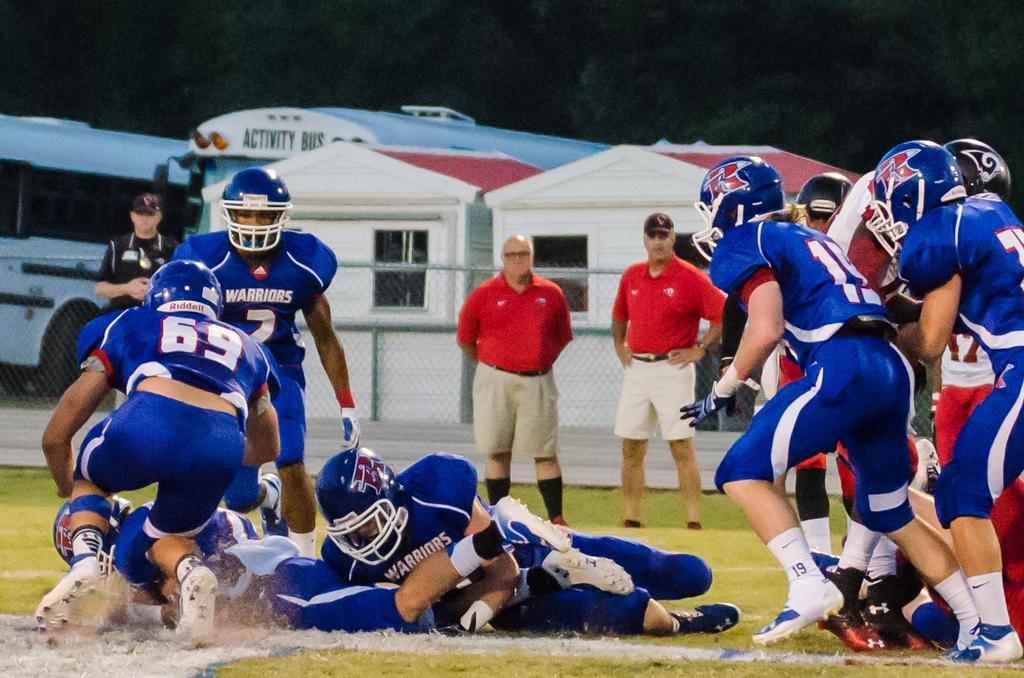How many people are in the image? There is a group of people in the image, but the exact number is not specified. What is the position of the people in the image? The people are on the ground in the image. What can be seen in the background of the image? In the background of the image, there is a fence, vehicles, sheds, and trees. What type of coast can be seen in the image? There is no coast visible in the image; it features a group of people on the ground with various background elements. 